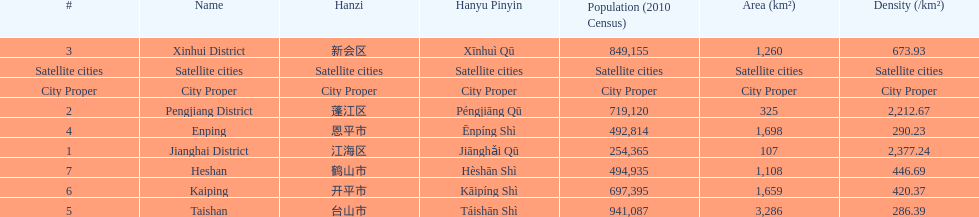Which area is the least dense? Taishan. 